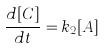Convert formula to latex. <formula><loc_0><loc_0><loc_500><loc_500>\frac { d [ C ] } { d t } = k _ { 2 } [ A ]</formula> 